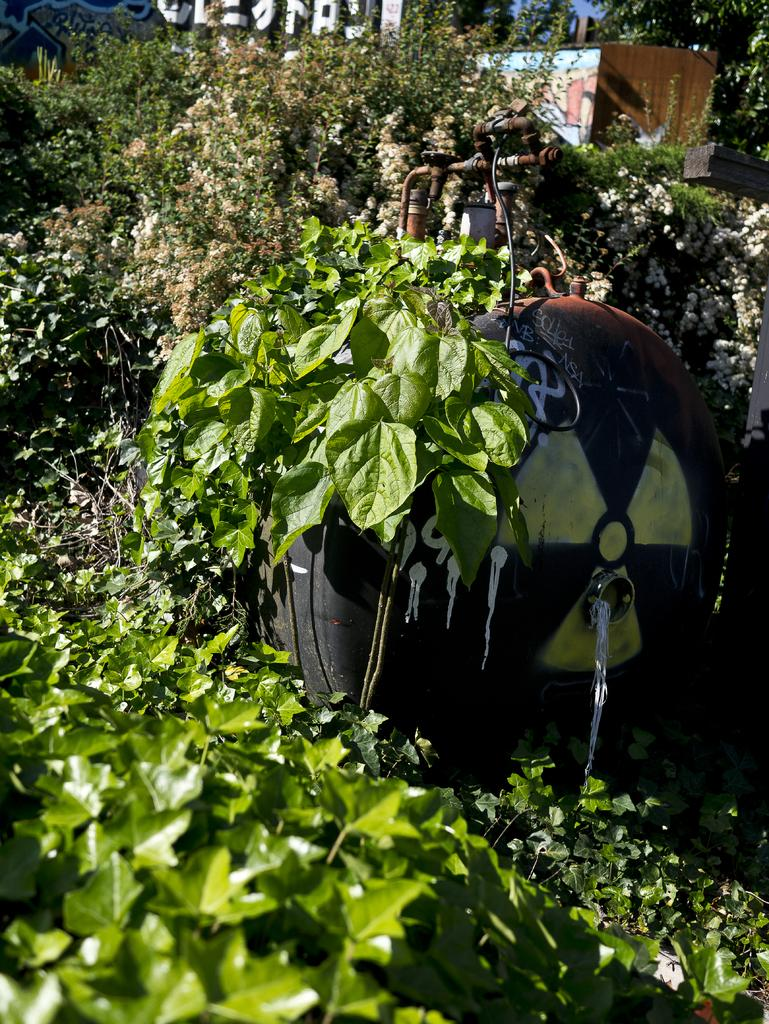What type of vegetation can be seen in the image? There are leaves in the image. What structure is present in the image? There is a water tank in the image. How many eggs are hidden in the cave in the image? There is no cave or eggs present in the image; it only features leaves and a water tank. 